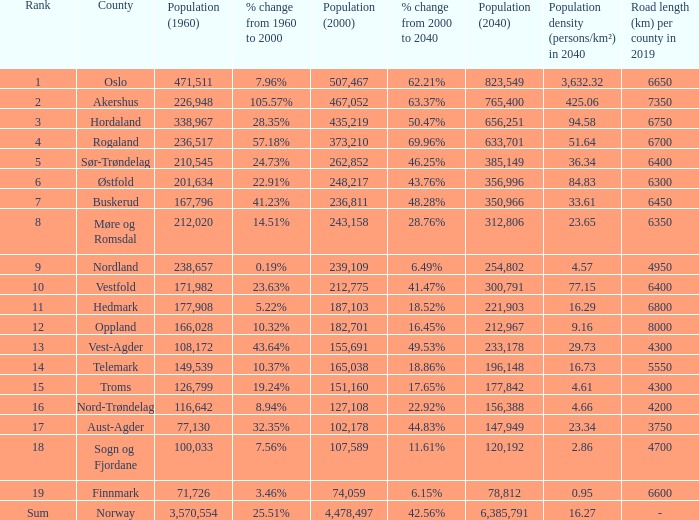What was the population of a county in 1960 that had a population of 467,052 in 2000 and 78,812 in 2040? None. 